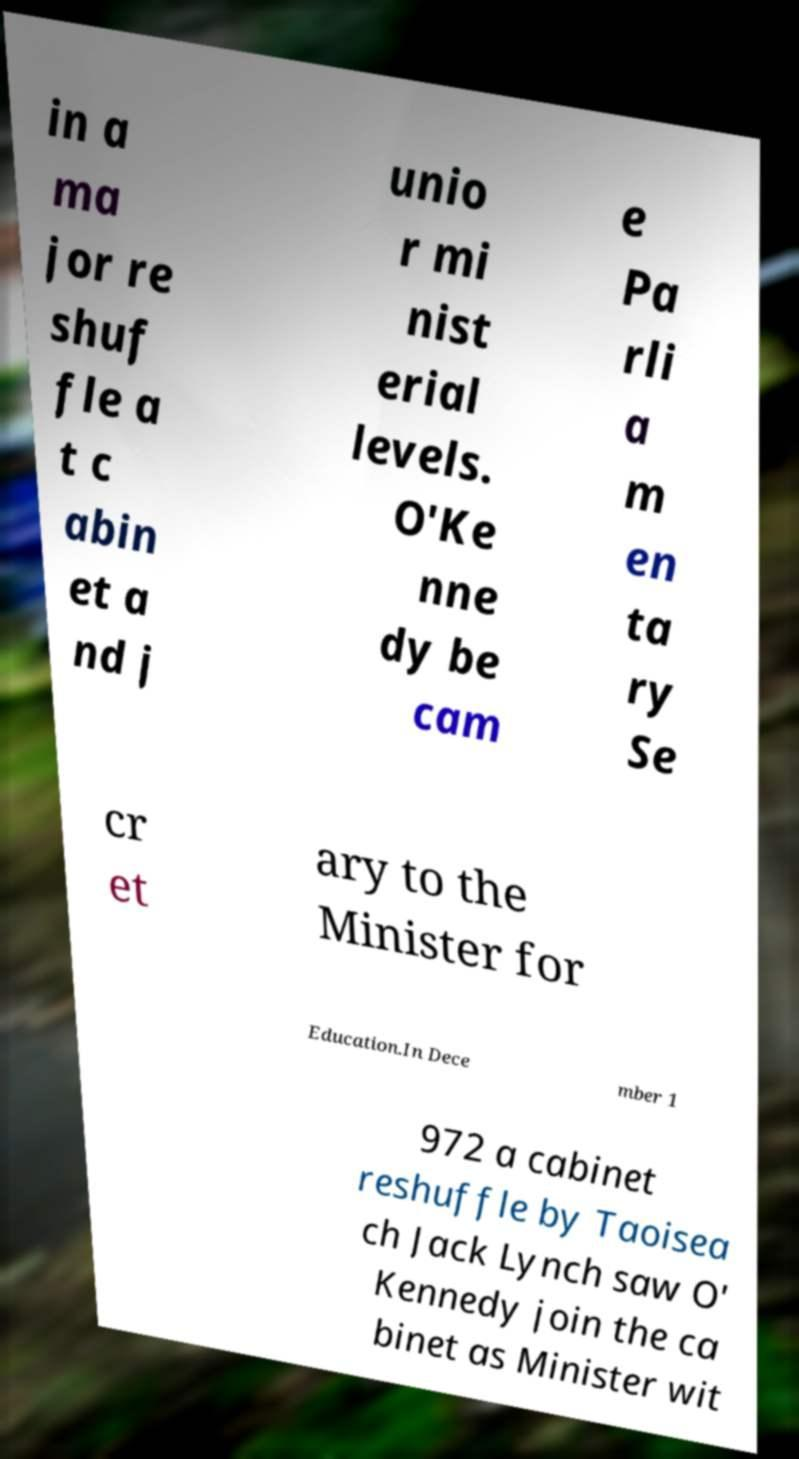Can you accurately transcribe the text from the provided image for me? in a ma jor re shuf fle a t c abin et a nd j unio r mi nist erial levels. O'Ke nne dy be cam e Pa rli a m en ta ry Se cr et ary to the Minister for Education.In Dece mber 1 972 a cabinet reshuffle by Taoisea ch Jack Lynch saw O' Kennedy join the ca binet as Minister wit 